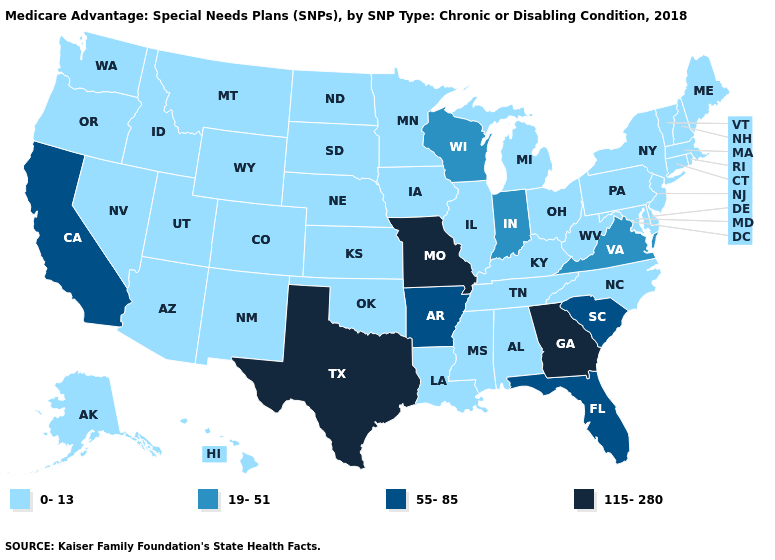Which states hav the highest value in the Northeast?
Write a very short answer. Connecticut, Massachusetts, Maine, New Hampshire, New Jersey, New York, Pennsylvania, Rhode Island, Vermont. What is the lowest value in states that border Ohio?
Short answer required. 0-13. Which states have the highest value in the USA?
Keep it brief. Georgia, Missouri, Texas. Does New Jersey have the same value as Louisiana?
Answer briefly. Yes. What is the lowest value in the USA?
Answer briefly. 0-13. Which states have the highest value in the USA?
Give a very brief answer. Georgia, Missouri, Texas. What is the value of New Hampshire?
Give a very brief answer. 0-13. Which states hav the highest value in the Northeast?
Quick response, please. Connecticut, Massachusetts, Maine, New Hampshire, New Jersey, New York, Pennsylvania, Rhode Island, Vermont. Does Michigan have the highest value in the MidWest?
Short answer required. No. What is the value of Louisiana?
Write a very short answer. 0-13. What is the highest value in the MidWest ?
Write a very short answer. 115-280. Name the states that have a value in the range 0-13?
Keep it brief. Alaska, Alabama, Arizona, Colorado, Connecticut, Delaware, Hawaii, Iowa, Idaho, Illinois, Kansas, Kentucky, Louisiana, Massachusetts, Maryland, Maine, Michigan, Minnesota, Mississippi, Montana, North Carolina, North Dakota, Nebraska, New Hampshire, New Jersey, New Mexico, Nevada, New York, Ohio, Oklahoma, Oregon, Pennsylvania, Rhode Island, South Dakota, Tennessee, Utah, Vermont, Washington, West Virginia, Wyoming. Name the states that have a value in the range 19-51?
Keep it brief. Indiana, Virginia, Wisconsin. Which states have the highest value in the USA?
Quick response, please. Georgia, Missouri, Texas. Name the states that have a value in the range 55-85?
Be succinct. Arkansas, California, Florida, South Carolina. 